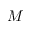<formula> <loc_0><loc_0><loc_500><loc_500>M</formula> 